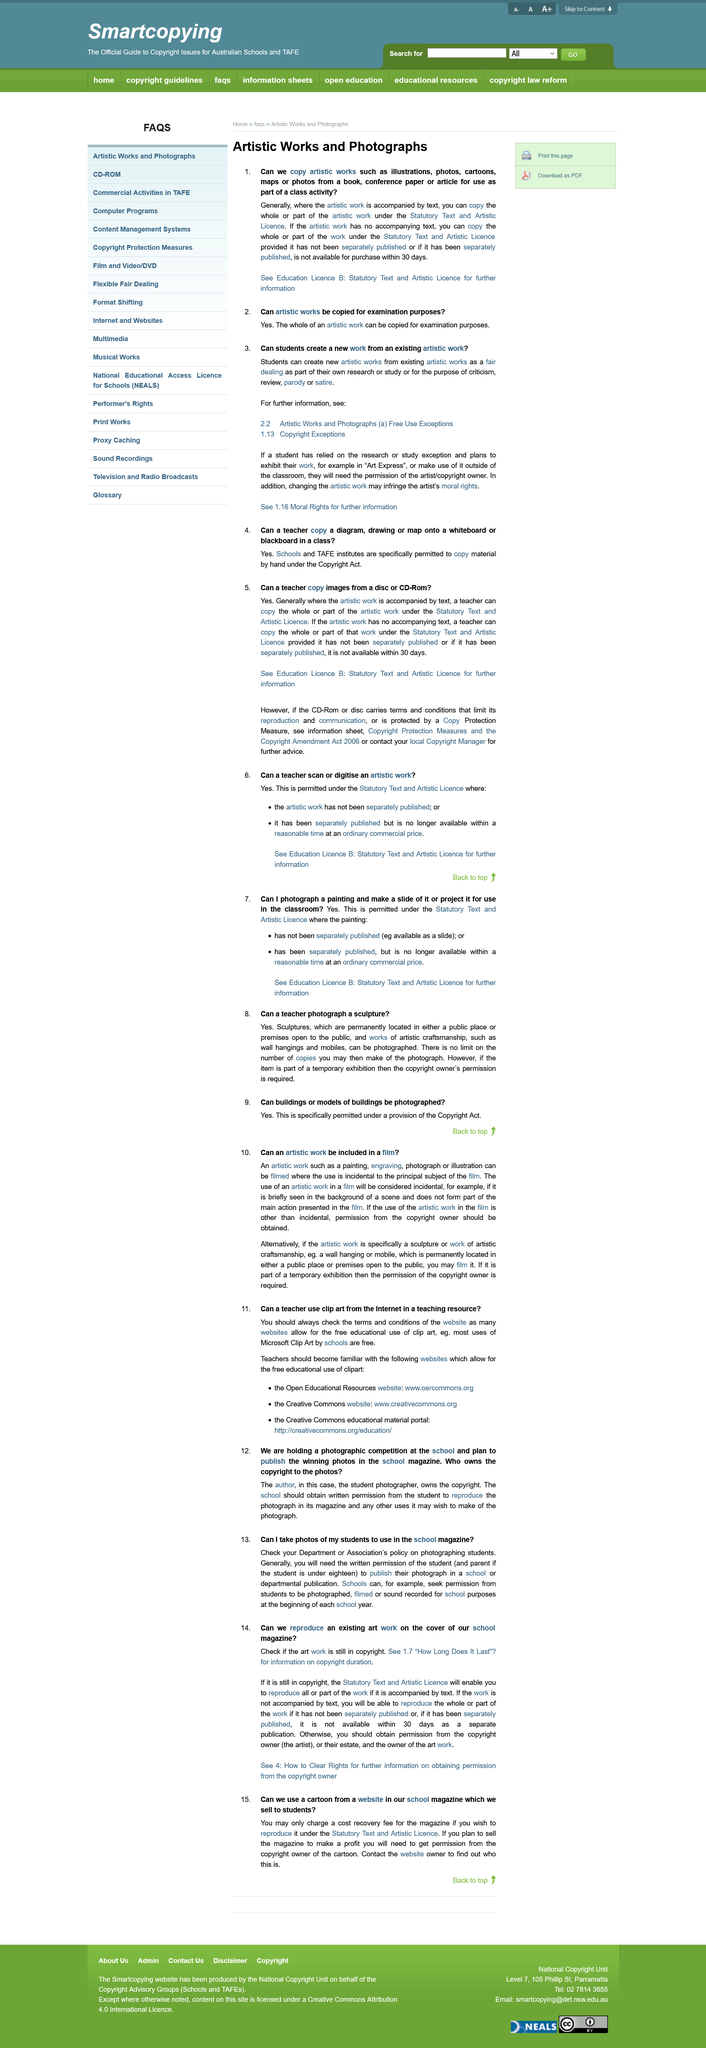Indicate a few pertinent items in this graphic. A teacher is permitted to copy an artistic work under the provisions of the Statutory Text and Artistic Licence. It is not necessary for a school to request permission every time they want to publish photos of students if the students have already consented at the beginning of the year, as long as the school is following the consent given by the students. It is generally necessary for a school to obtain written permission from the student or the student's parent if the student is a minor in order to take and use photos of the student in a school publication. However, the specific requirements may vary based on the area. It is permissible for a teacher to copy certain artistic works such as illustrations, cartoons, and maps in the classroom setting, as long as they are not the primary focus of the lesson and are used for educational purposes only. Teachers should be knowledgeable about websites that provide educational use of clipart, such as open educational resources, the creative commons, and the creative commons educational material portal, in order to promote the free use of clip art for educational purposes. 